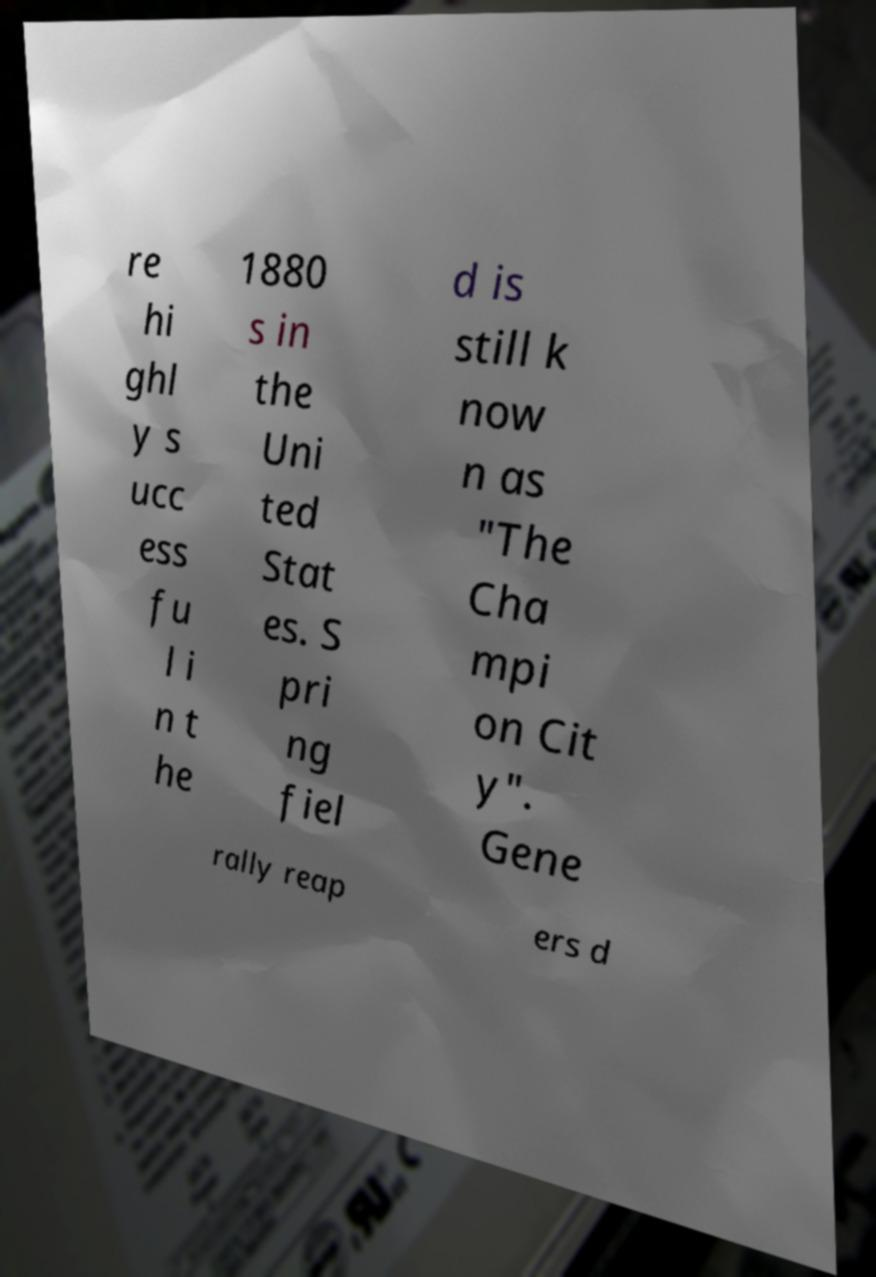I need the written content from this picture converted into text. Can you do that? re hi ghl y s ucc ess fu l i n t he 1880 s in the Uni ted Stat es. S pri ng fiel d is still k now n as "The Cha mpi on Cit y". Gene rally reap ers d 